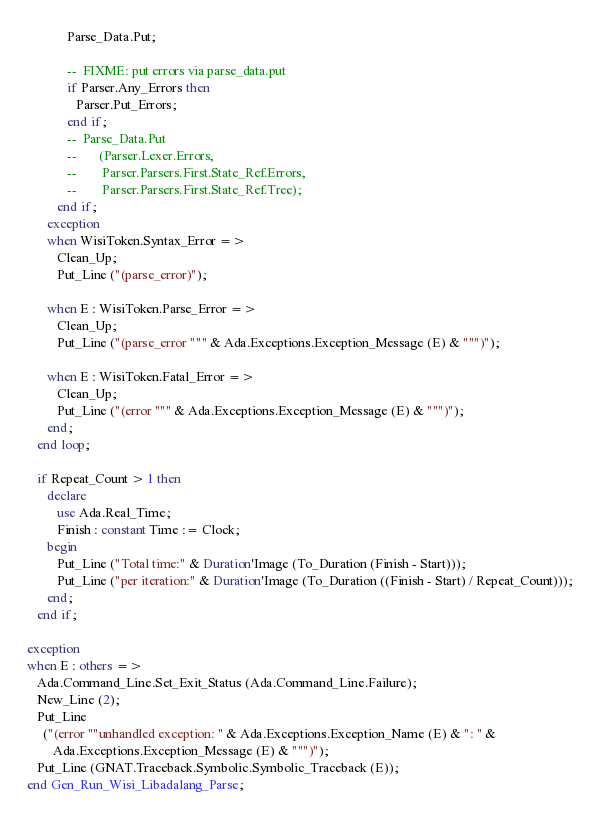<code> <loc_0><loc_0><loc_500><loc_500><_Ada_>            Parse_Data.Put;

            --  FIXME: put errors via parse_data.put
            if Parser.Any_Errors then
               Parser.Put_Errors;
            end if;
            --  Parse_Data.Put
            --       (Parser.Lexer.Errors,
            --        Parser.Parsers.First.State_Ref.Errors,
            --        Parser.Parsers.First.State_Ref.Tree);
         end if;
      exception
      when WisiToken.Syntax_Error =>
         Clean_Up;
         Put_Line ("(parse_error)");

      when E : WisiToken.Parse_Error =>
         Clean_Up;
         Put_Line ("(parse_error """ & Ada.Exceptions.Exception_Message (E) & """)");

      when E : WisiToken.Fatal_Error =>
         Clean_Up;
         Put_Line ("(error """ & Ada.Exceptions.Exception_Message (E) & """)");
      end;
   end loop;

   if Repeat_Count > 1 then
      declare
         use Ada.Real_Time;
         Finish : constant Time := Clock;
      begin
         Put_Line ("Total time:" & Duration'Image (To_Duration (Finish - Start)));
         Put_Line ("per iteration:" & Duration'Image (To_Duration ((Finish - Start) / Repeat_Count)));
      end;
   end if;

exception
when E : others =>
   Ada.Command_Line.Set_Exit_Status (Ada.Command_Line.Failure);
   New_Line (2);
   Put_Line
     ("(error ""unhandled exception: " & Ada.Exceptions.Exception_Name (E) & ": " &
        Ada.Exceptions.Exception_Message (E) & """)");
   Put_Line (GNAT.Traceback.Symbolic.Symbolic_Traceback (E));
end Gen_Run_Wisi_Libadalang_Parse;
</code> 